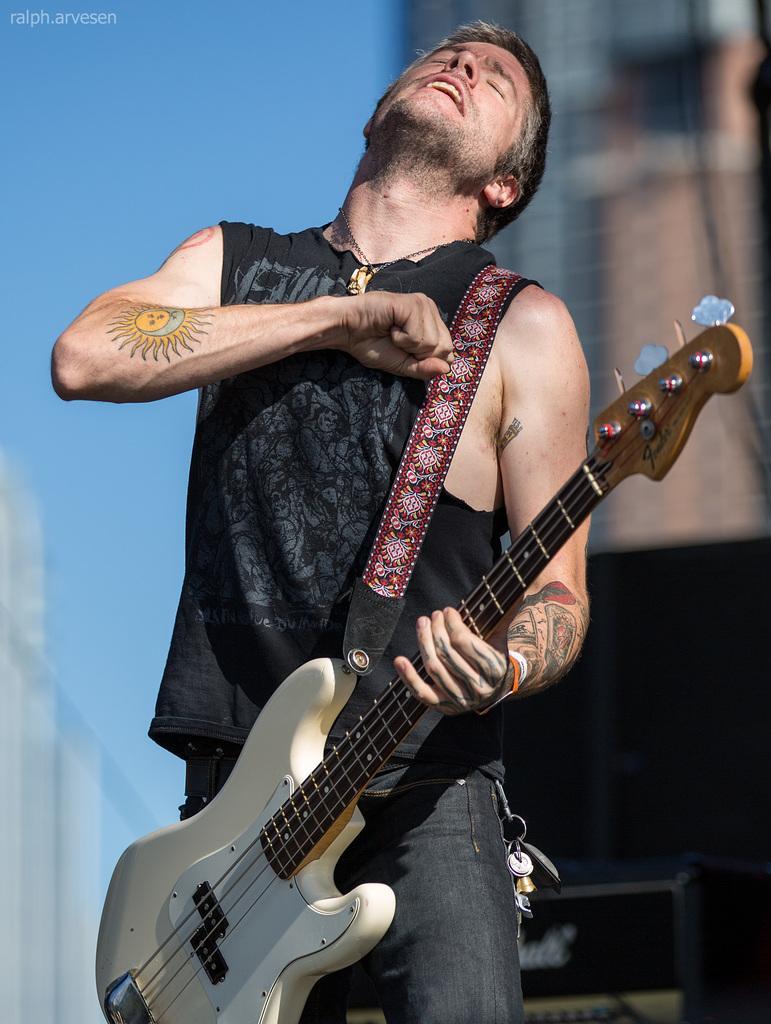Could you give a brief overview of what you see in this image? In this picture the man and he is standing and singing, he is holding the guitar with his left hand and he kept his right hand at his chest there are some keys in his pocket and in the background is a building in the sky is clear 